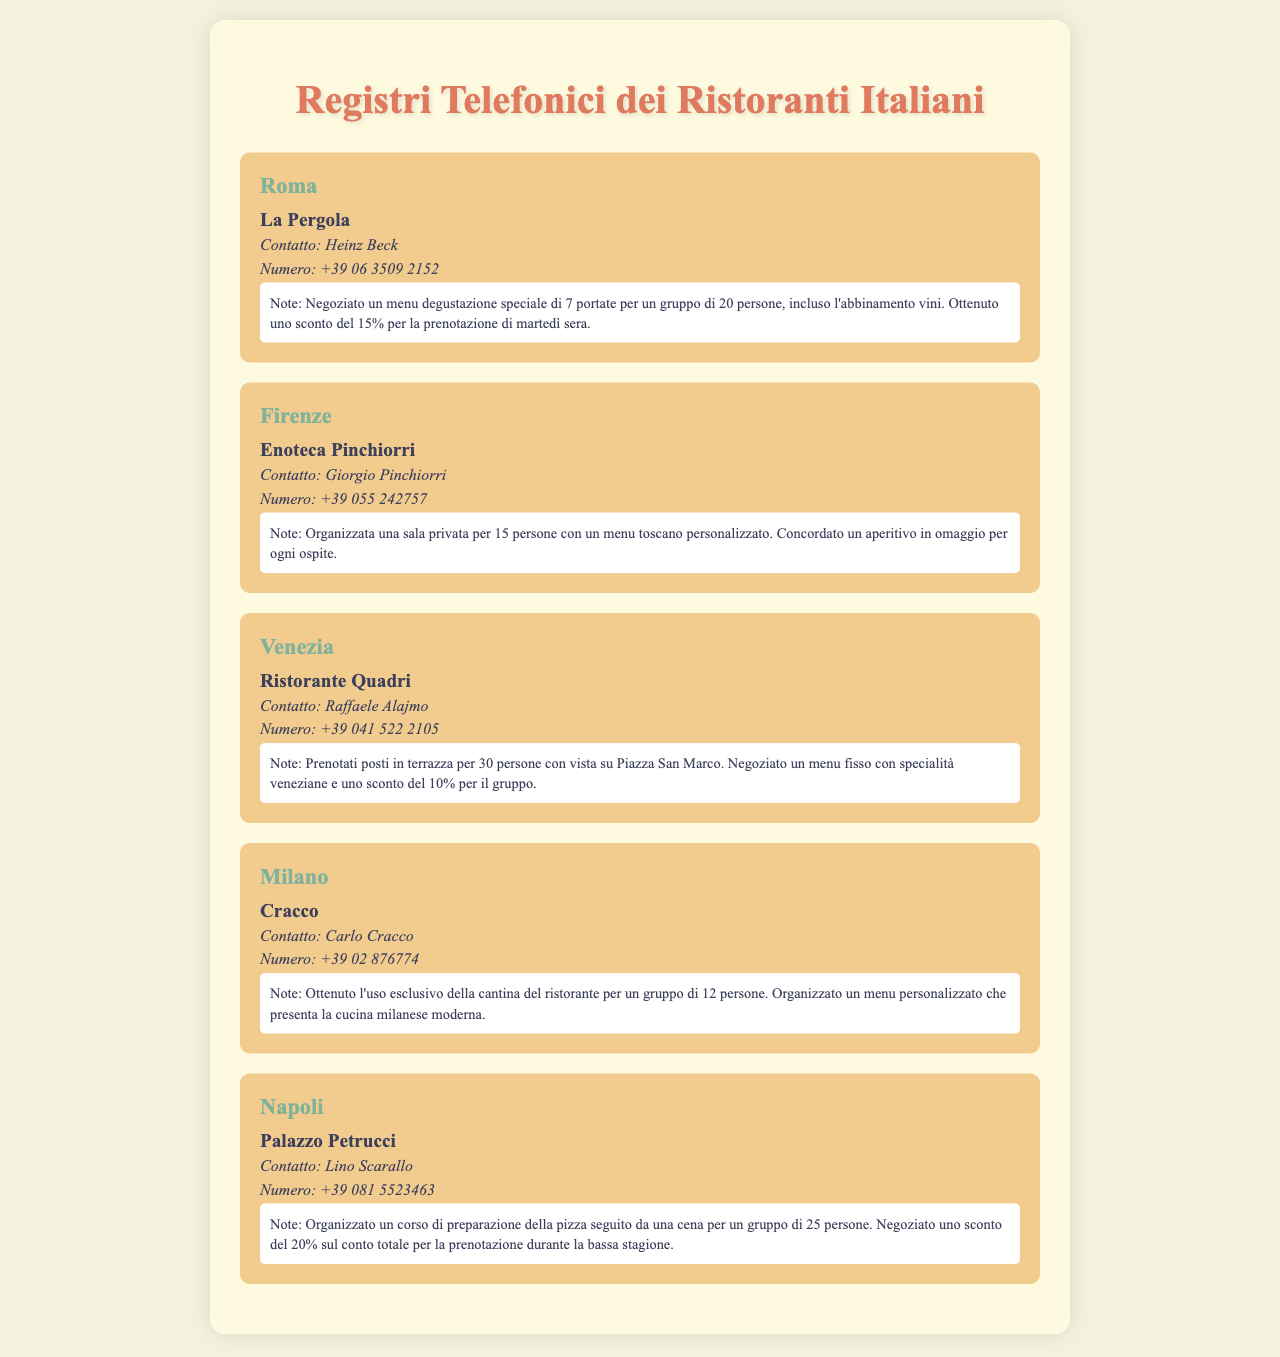Qual è il nome del ristorante a Roma? Il nome del ristorante a Roma è La Pergola.
Answer: La Pergola Chi è il contatto per il ristorante a Firenze? Il contatto per il ristorante a Firenze è Giorgio Pinchiorri.
Answer: Giorgio Pinchiorri Qual è il numero di telefono di Ristorante Quadri? Il numero di telefono di Ristorante Quadri è +39 041 522 2105.
Answer: +39 041 522 2105 Qual è lo sconto negoziato per il ristorante Palazzo Petrucci? Lo sconto negoziato per Palazzo Petrucci è del 20%.
Answer: 20% Quante persone possono essere accommodate in terrazza a Ristorante Quadri? Ristorante Quadri può accomodare 30 persone in terrazza.
Answer: 30 persone Qual è il menu speciale organizzato per il gruppo a La Pergola? Il menu speciale organizzato a La Pergola è un menu degustazione di 7 portate.
Answer: menu degustazione di 7 portate Che tipo di esperienza è stata organizzata al ristorante Cracco? Al ristorante Cracco è stata organizzata un'esperienza con un menu personalizzato.
Answer: menu personalizzato Quale bevanda è stata concordata come omaggio per il ristorante Enoteca Pinchiorri? È stato concordato un aperitivo in omaggio per ogni ospite.
Answer: aperitivo Qual è la location per la cena di gruppo a Palazzo Petrucci? La location per la cena è un corso di preparazione della pizza.
Answer: corso di preparazione della pizza 